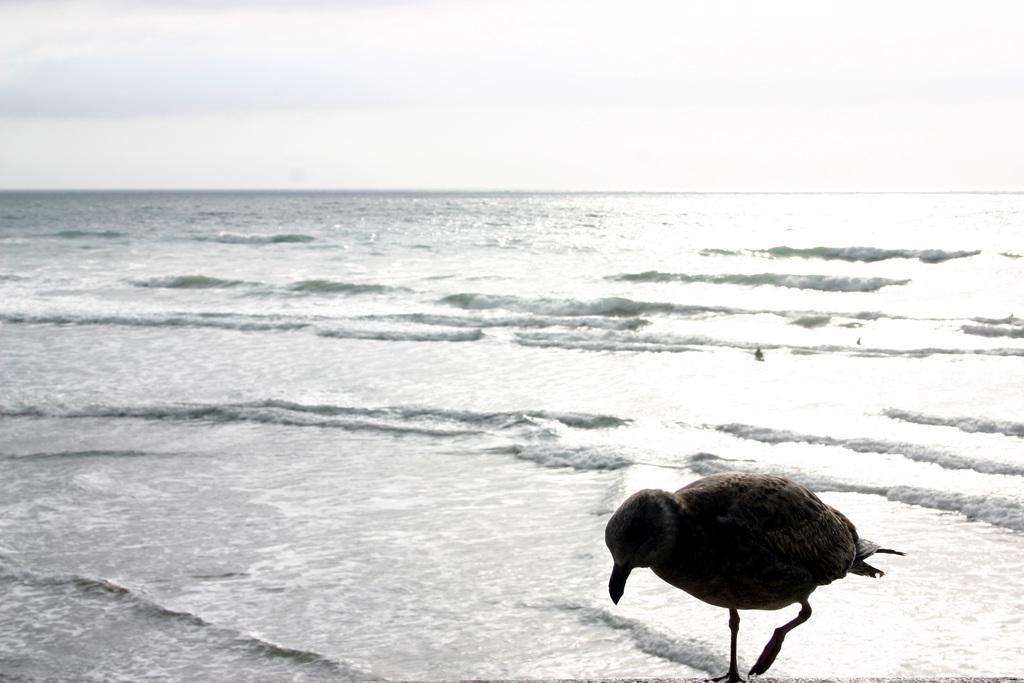Please provide a concise description of this image. There is a bird standing. In the background, there are tides of an ocean and there are clouds in the sky. 